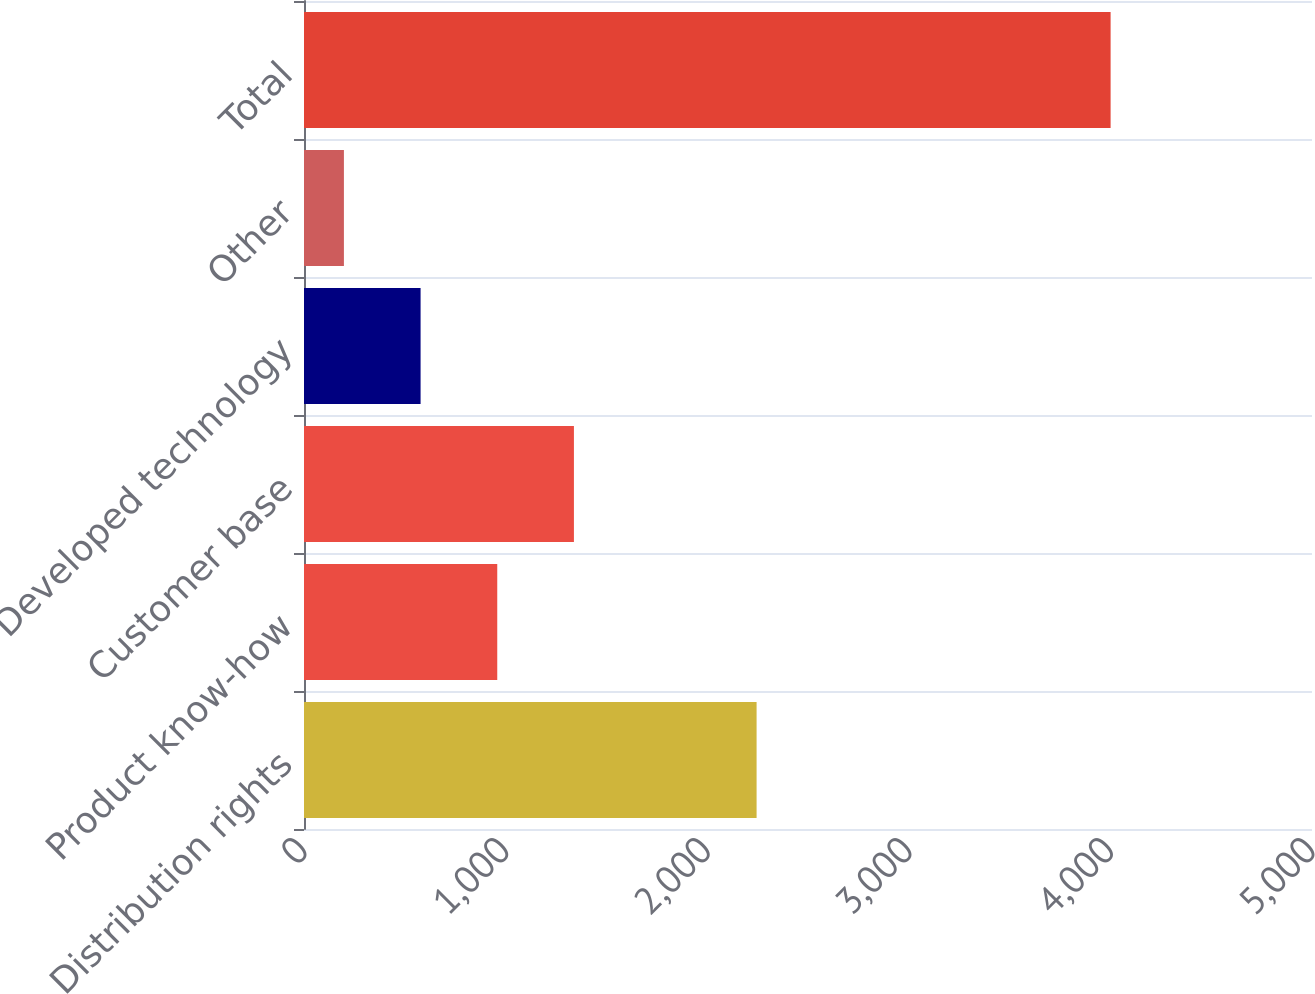Convert chart. <chart><loc_0><loc_0><loc_500><loc_500><bar_chart><fcel>Distribution rights<fcel>Product know-how<fcel>Customer base<fcel>Developed technology<fcel>Other<fcel>Total<nl><fcel>2245<fcel>958.6<fcel>1338.9<fcel>578.3<fcel>198<fcel>4001<nl></chart> 